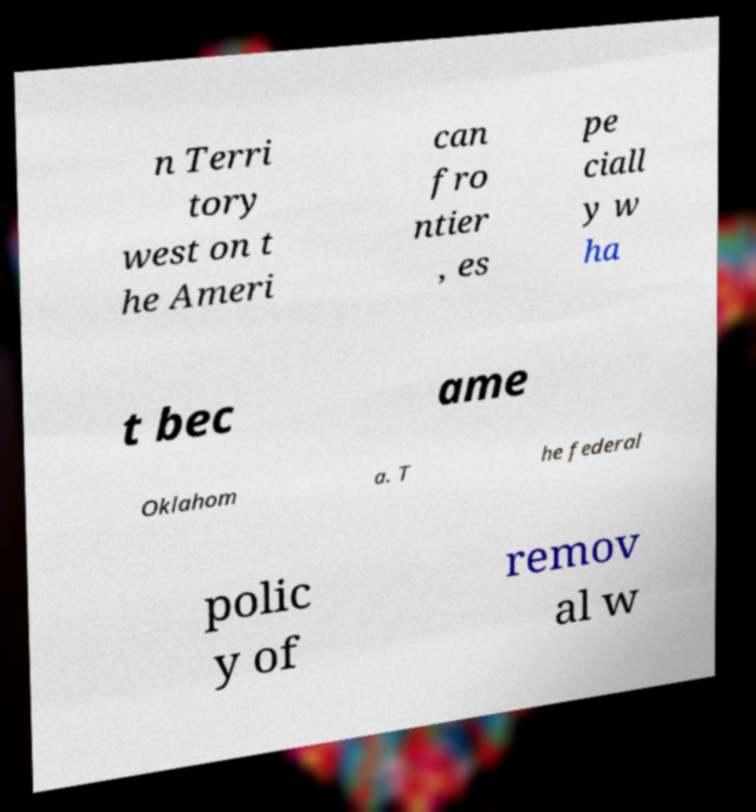Could you assist in decoding the text presented in this image and type it out clearly? n Terri tory west on t he Ameri can fro ntier , es pe ciall y w ha t bec ame Oklahom a. T he federal polic y of remov al w 